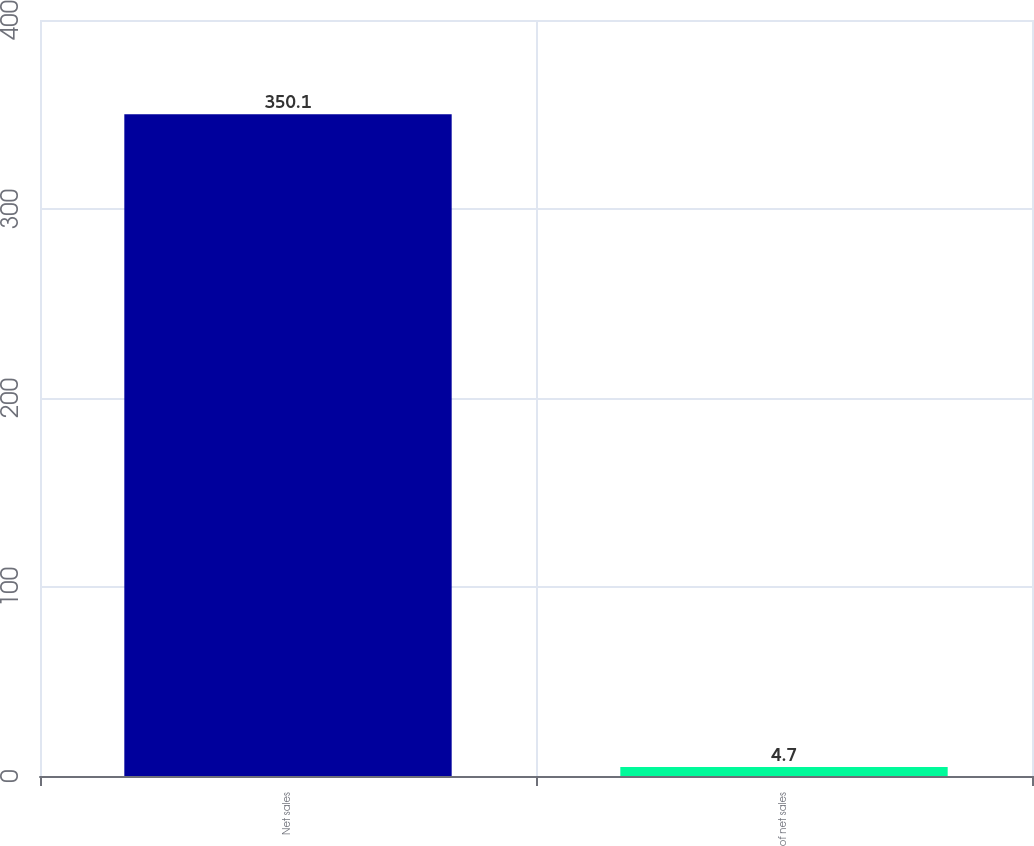Convert chart to OTSL. <chart><loc_0><loc_0><loc_500><loc_500><bar_chart><fcel>Net sales<fcel>of net sales<nl><fcel>350.1<fcel>4.7<nl></chart> 